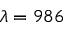<formula> <loc_0><loc_0><loc_500><loc_500>\lambda = 9 8 6</formula> 